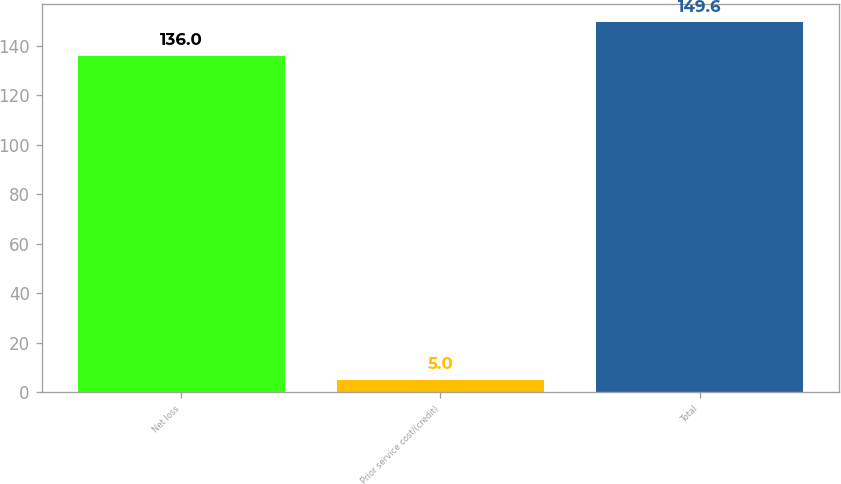Convert chart to OTSL. <chart><loc_0><loc_0><loc_500><loc_500><bar_chart><fcel>Net loss<fcel>Prior service cost/(credit)<fcel>Total<nl><fcel>136<fcel>5<fcel>149.6<nl></chart> 